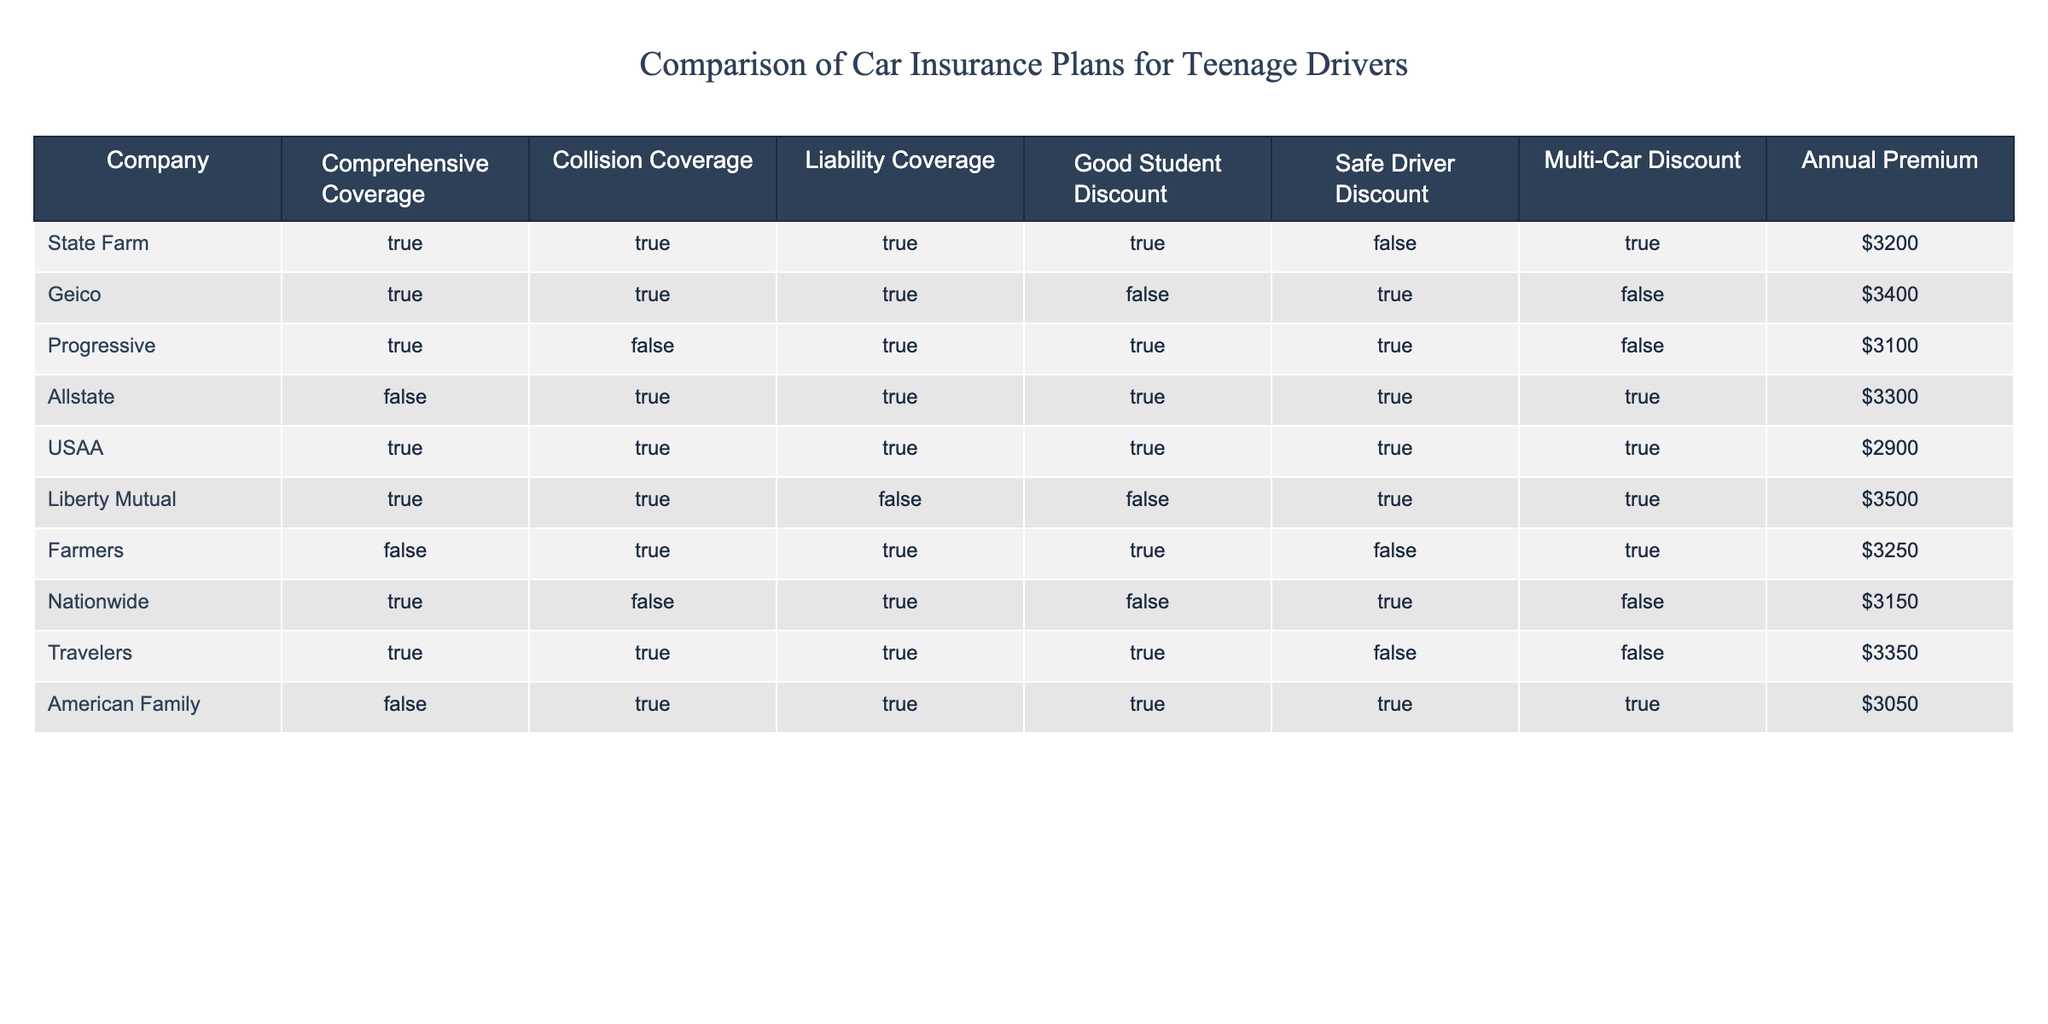What is the annual premium for USAA? The table shows that USAA has an annual premium of 2900.
Answer: 2900 Which companies offer both Comprehensive and Collision coverage? By looking at the table, State Farm, Geico, Progressive, Liberty Mutual, Travelers, and USAA all have 'TRUE' in both the Comprehensive and Collision coverage columns.
Answer: State Farm, Geico, Progressive, Liberty Mutual, Travelers, USAA Is Farmers eligible for a Good Student Discount? The table indicates that Farmers has 'FALSE' in the Good Student Discount column. Thus, Farmers is not eligible for this discount.
Answer: No What is the total number of companies offering Multi-Car Discounts? In the table, there are four companies that have 'TRUE' for the Multi-Car Discount: State Farm, Liberty Mutual, Farmers, and USAA. Therefore, the total is 4.
Answer: 4 Which company's annual premium is the highest? The highest annual premium in the table is for Liberty Mutual, which is 3500.
Answer: Liberty Mutual Does Geico provide a Safe Driver Discount? According to the table, Geico has 'TRUE' in the Safe Driver Discount column. Hence, Geico does provide this discount.
Answer: Yes Which company offers the lowest annual premium and what is it? Looking through the table, USAA offers the lowest annual premium at 2900.
Answer: USAA, 2900 If a driver qualifies for both the Good Student and Safe Driver Discounts, which companies would they be eligible for? The companies in the table that have 'TRUE' for both Good Student Discount and Safe Driver Discount are Progressive and Allstate. Therefore, those are the companies they could be eligible for.
Answer: Progressive, Allstate How much more would a driver pay for insurance with Liberty Mutual compared to USAA? The annual premium for Liberty Mutual is 3500 and for USAA is 2900. The difference is 3500 - 2900 = 600.
Answer: 600 